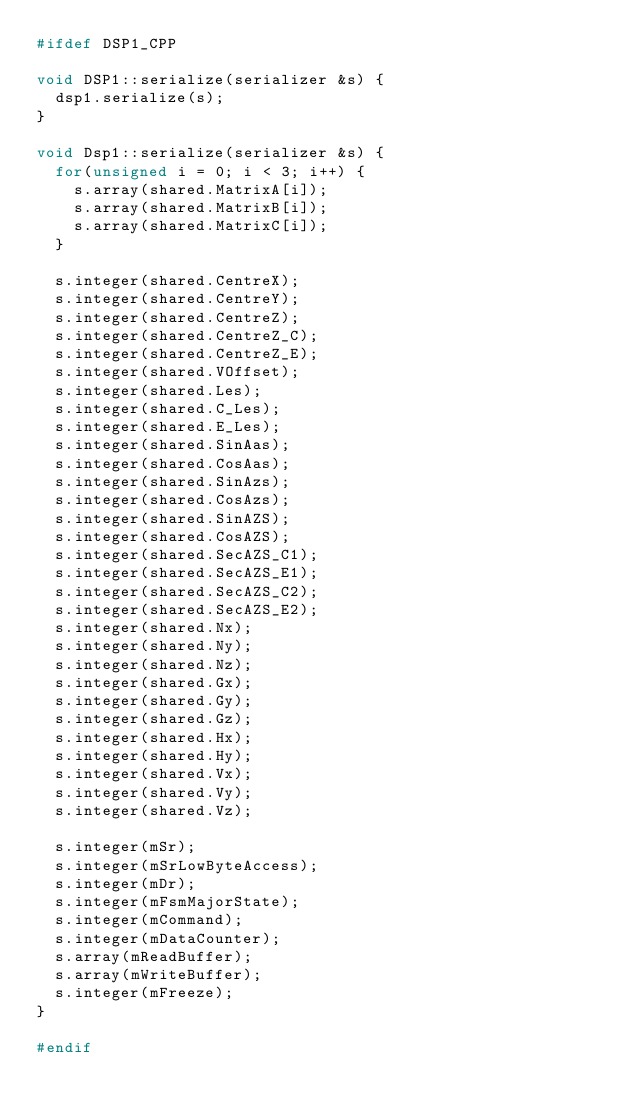Convert code to text. <code><loc_0><loc_0><loc_500><loc_500><_C++_>#ifdef DSP1_CPP

void DSP1::serialize(serializer &s) {
  dsp1.serialize(s);
}

void Dsp1::serialize(serializer &s) {
  for(unsigned i = 0; i < 3; i++) {
    s.array(shared.MatrixA[i]);
    s.array(shared.MatrixB[i]);
    s.array(shared.MatrixC[i]);
  }

  s.integer(shared.CentreX);
  s.integer(shared.CentreY);
  s.integer(shared.CentreZ);
  s.integer(shared.CentreZ_C);
  s.integer(shared.CentreZ_E);
  s.integer(shared.VOffset);
  s.integer(shared.Les);
  s.integer(shared.C_Les);
  s.integer(shared.E_Les);
  s.integer(shared.SinAas);
  s.integer(shared.CosAas);
  s.integer(shared.SinAzs);
  s.integer(shared.CosAzs);
  s.integer(shared.SinAZS);
  s.integer(shared.CosAZS);
  s.integer(shared.SecAZS_C1);
  s.integer(shared.SecAZS_E1);
  s.integer(shared.SecAZS_C2);
  s.integer(shared.SecAZS_E2);
  s.integer(shared.Nx);
  s.integer(shared.Ny);
  s.integer(shared.Nz);
  s.integer(shared.Gx);
  s.integer(shared.Gy);
  s.integer(shared.Gz);
  s.integer(shared.Hx);
  s.integer(shared.Hy);
  s.integer(shared.Vx);
  s.integer(shared.Vy);
  s.integer(shared.Vz);

  s.integer(mSr);
  s.integer(mSrLowByteAccess);
  s.integer(mDr);
  s.integer(mFsmMajorState);
  s.integer(mCommand);
  s.integer(mDataCounter);
  s.array(mReadBuffer);
  s.array(mWriteBuffer);
  s.integer(mFreeze);
}

#endif
</code> 